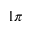Convert formula to latex. <formula><loc_0><loc_0><loc_500><loc_500>1 \pi</formula> 